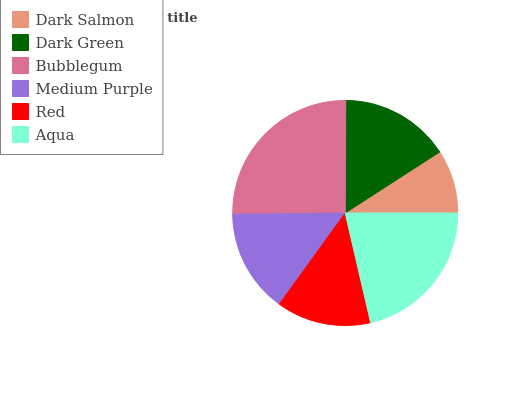Is Dark Salmon the minimum?
Answer yes or no. Yes. Is Bubblegum the maximum?
Answer yes or no. Yes. Is Dark Green the minimum?
Answer yes or no. No. Is Dark Green the maximum?
Answer yes or no. No. Is Dark Green greater than Dark Salmon?
Answer yes or no. Yes. Is Dark Salmon less than Dark Green?
Answer yes or no. Yes. Is Dark Salmon greater than Dark Green?
Answer yes or no. No. Is Dark Green less than Dark Salmon?
Answer yes or no. No. Is Dark Green the high median?
Answer yes or no. Yes. Is Medium Purple the low median?
Answer yes or no. Yes. Is Medium Purple the high median?
Answer yes or no. No. Is Red the low median?
Answer yes or no. No. 